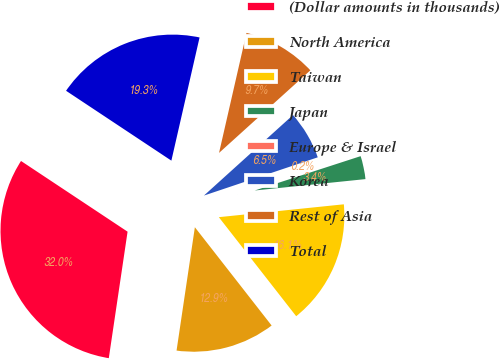Convert chart to OTSL. <chart><loc_0><loc_0><loc_500><loc_500><pie_chart><fcel>(Dollar amounts in thousands)<fcel>North America<fcel>Taiwan<fcel>Japan<fcel>Europe & Israel<fcel>Korea<fcel>Rest of Asia<fcel>Total<nl><fcel>31.98%<fcel>12.9%<fcel>16.08%<fcel>3.36%<fcel>0.17%<fcel>6.54%<fcel>9.72%<fcel>19.26%<nl></chart> 